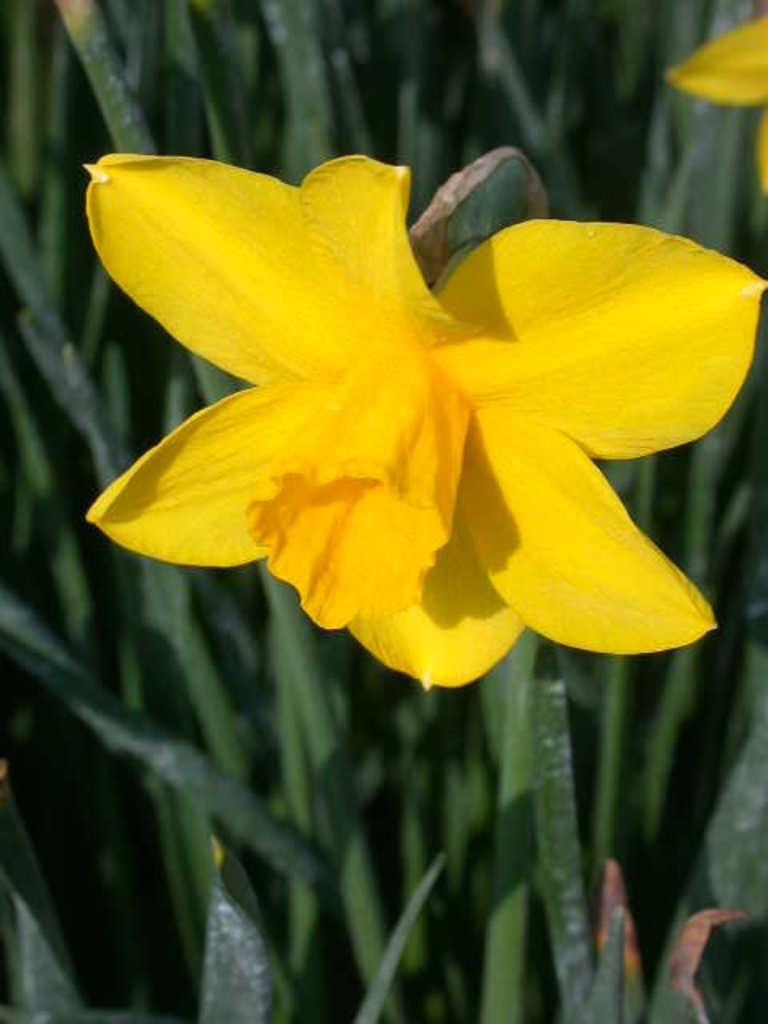What is the main subject of the image? The main subject of the image is a flower. What color is the flower? The flower has a yellow color. Where is the flower located? The flower is on a green plant. What type of glove is being used to increase the size of the flower in the image? There is no glove or attempt to increase the size of the flower in the image; it is a natural flower on a green plant. 